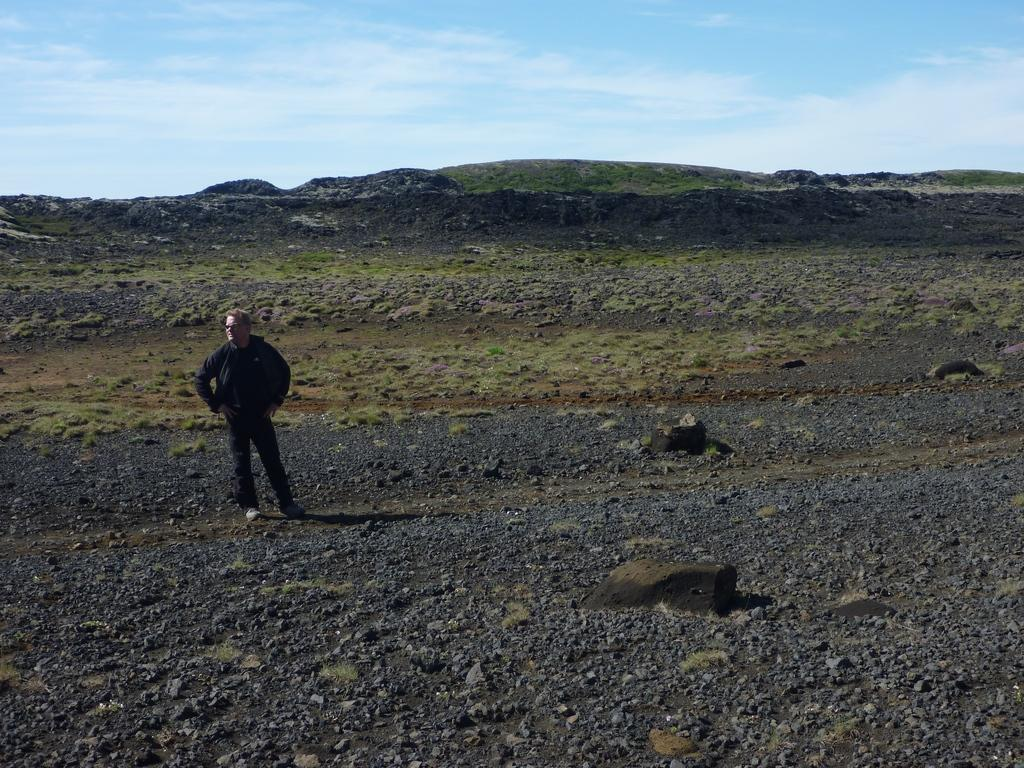What is the main subject of the image? There is a man standing in the center of the image. What type of surface is the man standing on? The ground in the background of the image is covered with grass. What can be seen in the sky in the background of the image? The sky is cloudy in the background of the image. What type of vase is visible in the image? There is no vase present in the image. What color is the paint on the man's shirt in the image? The provided facts do not mention the color of the man's shirt or any paint on it. What type of music is being played by the band in the image? There is no band present in the image. 